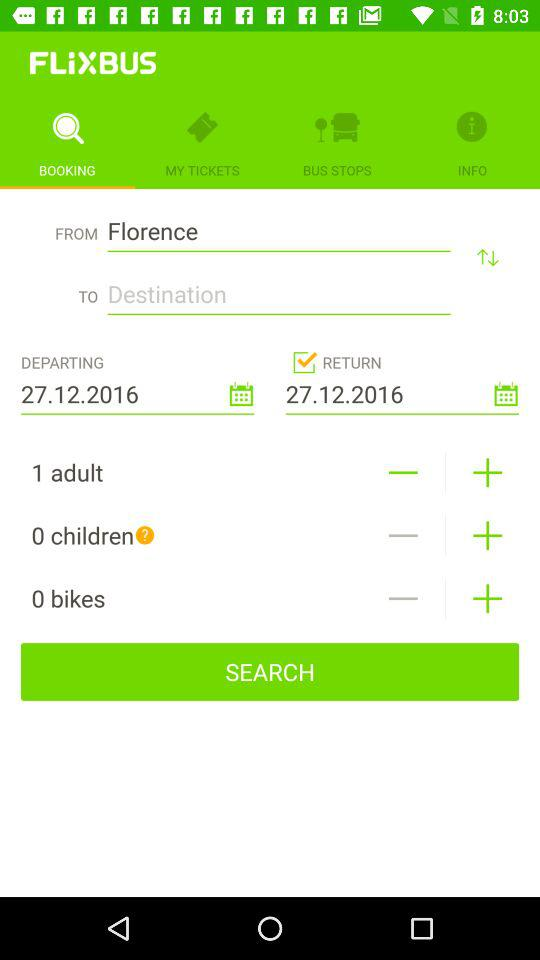How many more adults than children are there in this booking?
Answer the question using a single word or phrase. 1 